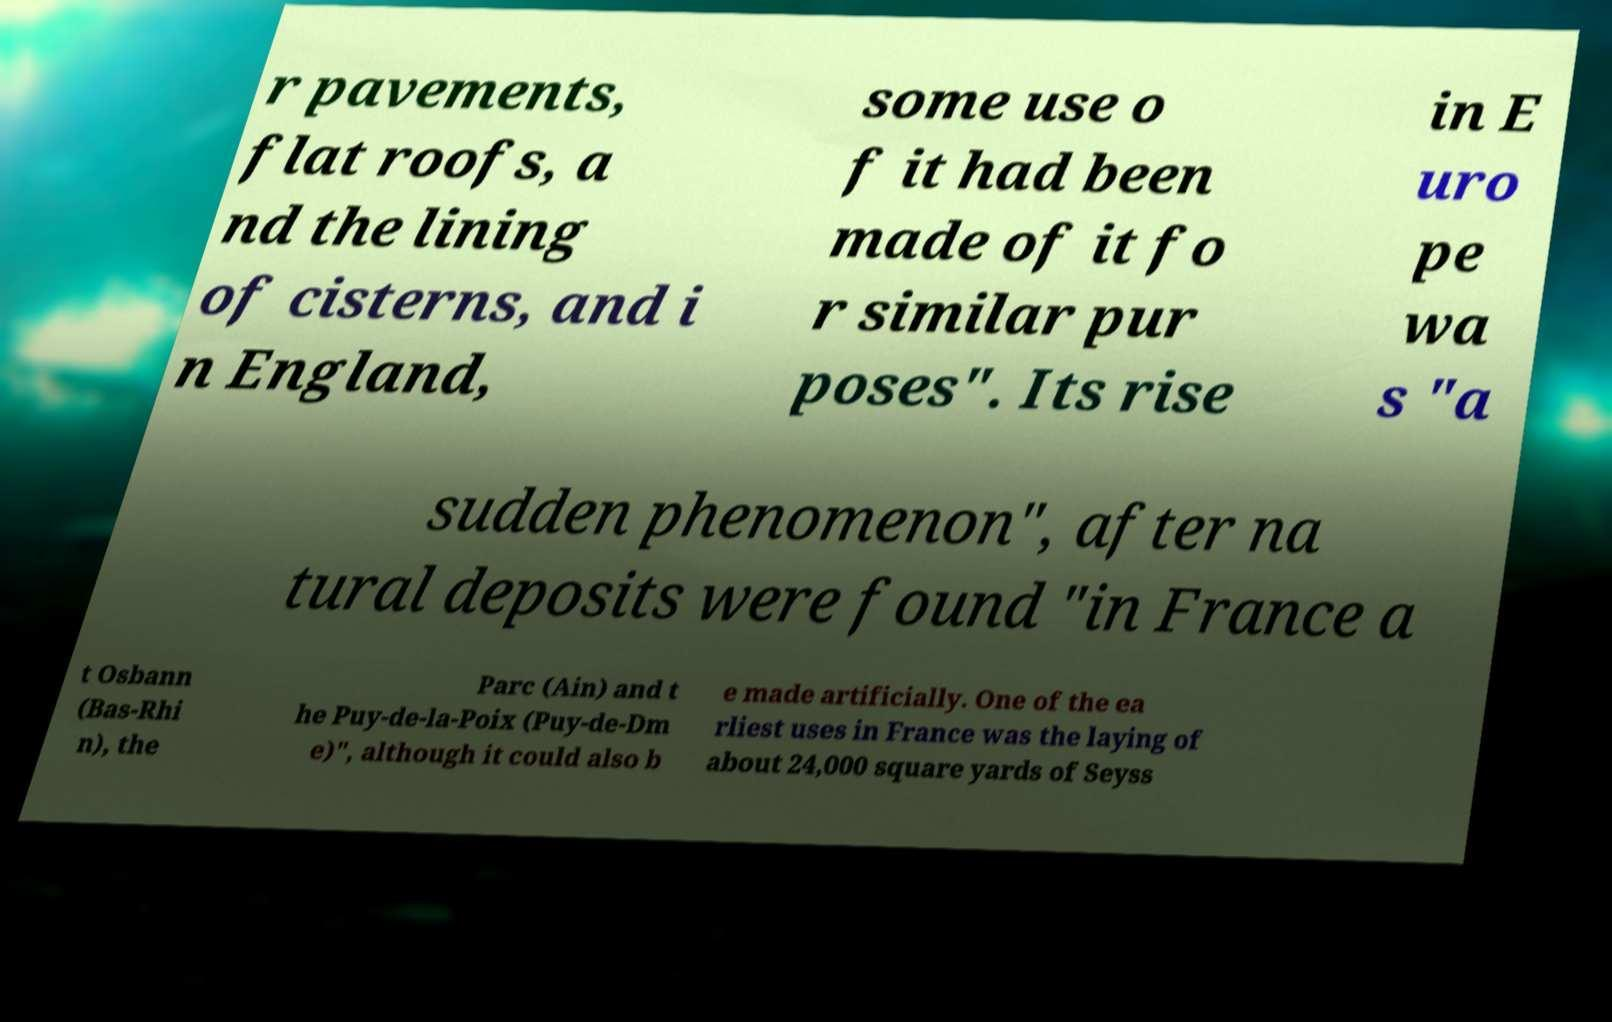Could you assist in decoding the text presented in this image and type it out clearly? r pavements, flat roofs, a nd the lining of cisterns, and i n England, some use o f it had been made of it fo r similar pur poses". Its rise in E uro pe wa s "a sudden phenomenon", after na tural deposits were found "in France a t Osbann (Bas-Rhi n), the Parc (Ain) and t he Puy-de-la-Poix (Puy-de-Dm e)", although it could also b e made artificially. One of the ea rliest uses in France was the laying of about 24,000 square yards of Seyss 